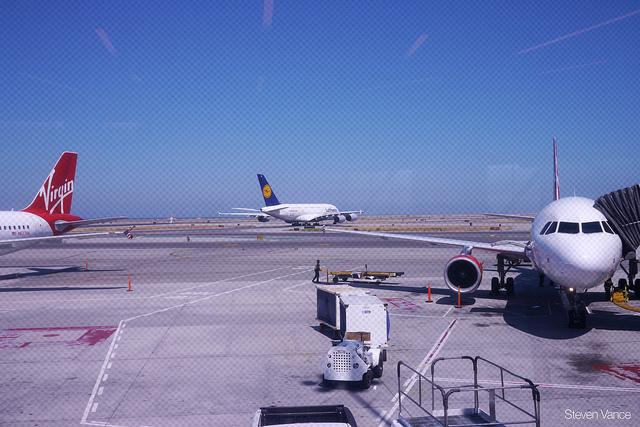Who owns the vehicle on the left? Please explain your reasoning. virgin atlantic. Virgin atlantic is on the left. 